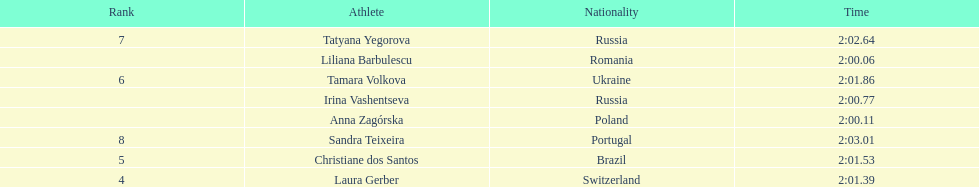What was the time difference between the first place finisher and the eighth place finisher? 2.95. 